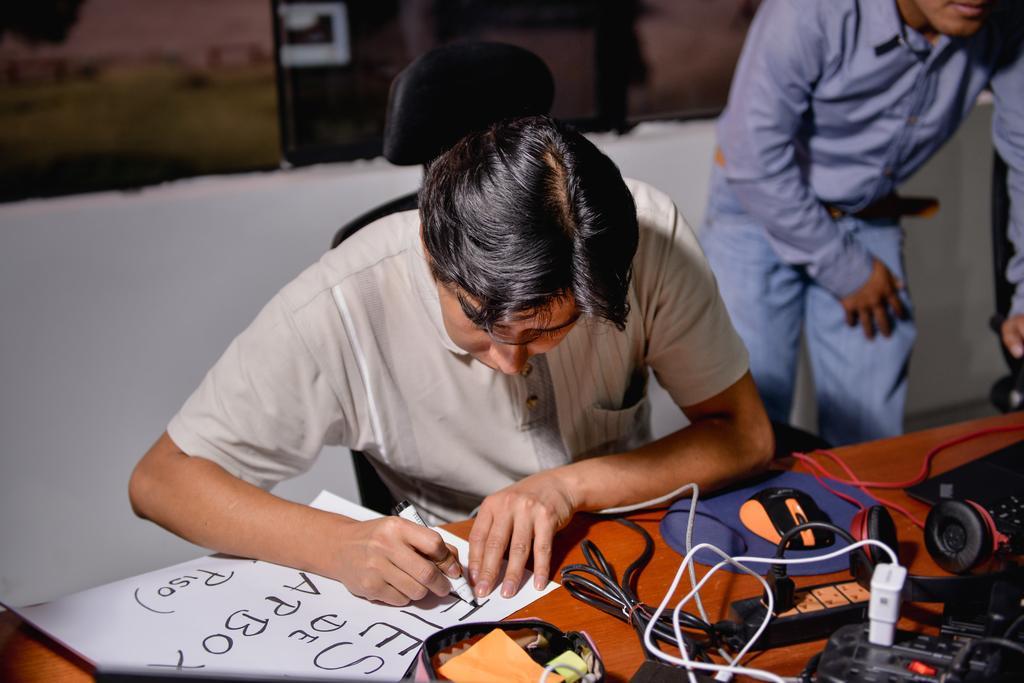Please provide a concise description of this image. In this picture we can see a person holding a marker in hand. He is writing on a white paper. There are few wires, switchboards and a laptop. We can see a man on the right side. A compound wall is visible from left to right. 